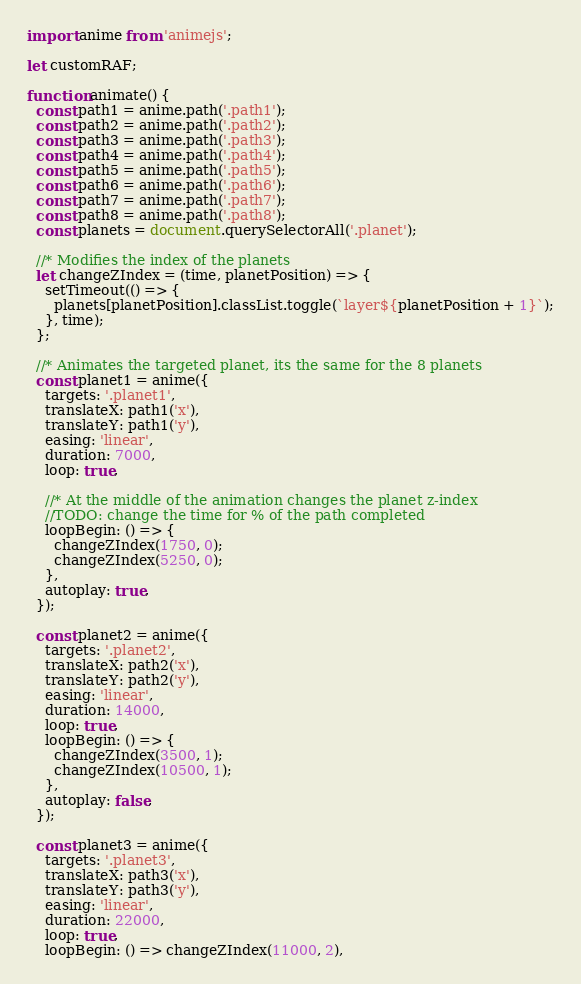Convert code to text. <code><loc_0><loc_0><loc_500><loc_500><_JavaScript_>import anime from 'animejs'; 

let customRAF;

function animate() {
  const path1 = anime.path('.path1');
  const path2 = anime.path('.path2');
  const path3 = anime.path('.path3');
  const path4 = anime.path('.path4');
  const path5 = anime.path('.path5');
  const path6 = anime.path('.path6');
  const path7 = anime.path('.path7');
  const path8 = anime.path('.path8');
  const planets = document.querySelectorAll('.planet');

  //* Modifies the index of the planets
  let changeZIndex = (time, planetPosition) => {
    setTimeout(() => {
      planets[planetPosition].classList.toggle(`layer${planetPosition + 1}`);
    }, time);
  };

  //* Animates the targeted planet, its the same for the 8 planets
  const planet1 = anime({
    targets: '.planet1',
    translateX: path1('x'),
    translateY: path1('y'),
    easing: 'linear',
    duration: 7000,
    loop: true,

    //* At the middle of the animation changes the planet z-index
    //TODO: change the time for % of the path completed
    loopBegin: () => {
      changeZIndex(1750, 0);
      changeZIndex(5250, 0);
    },
    autoplay: true,
  });

  const planet2 = anime({
    targets: '.planet2',
    translateX: path2('x'),
    translateY: path2('y'),
    easing: 'linear',
    duration: 14000,
    loop: true,
    loopBegin: () => {
      changeZIndex(3500, 1);
      changeZIndex(10500, 1);
    },
    autoplay: false,
  });
  
  const planet3 = anime({
    targets: '.planet3',
    translateX: path3('x'),
    translateY: path3('y'),
    easing: 'linear',
    duration: 22000,
    loop: true,
    loopBegin: () => changeZIndex(11000, 2),</code> 